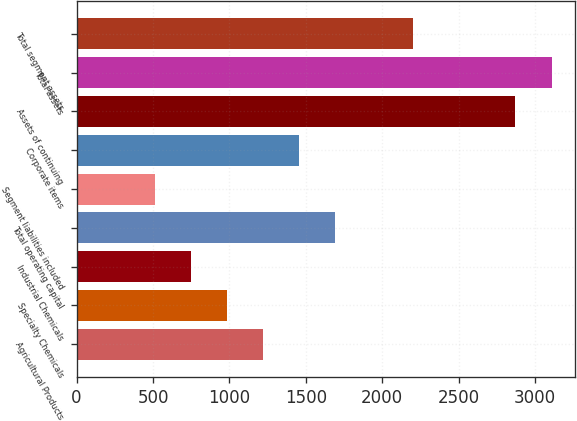Convert chart. <chart><loc_0><loc_0><loc_500><loc_500><bar_chart><fcel>Agricultural Products<fcel>Specialty Chemicals<fcel>Industrial Chemicals<fcel>Total operating capital<fcel>Segment liabilities included<fcel>Corporate items<fcel>Assets of continuing<fcel>Total assets<fcel>Total segment assets<nl><fcel>1219.09<fcel>982.96<fcel>746.83<fcel>1691.8<fcel>510.7<fcel>1455.22<fcel>2872<fcel>3108.13<fcel>2202.5<nl></chart> 